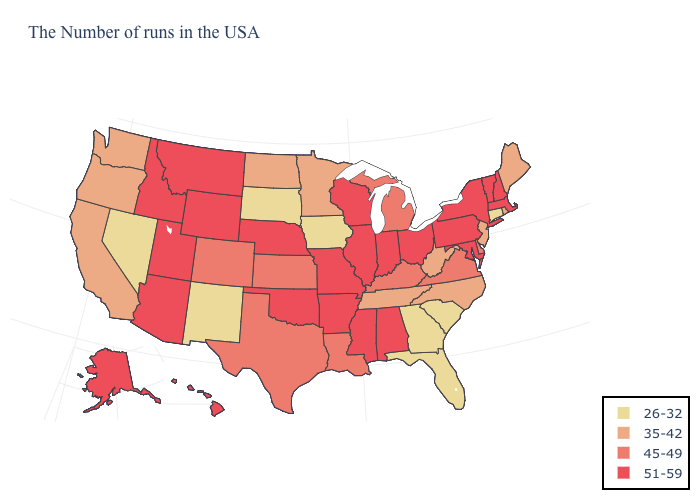Does the first symbol in the legend represent the smallest category?
Be succinct. Yes. What is the value of Idaho?
Short answer required. 51-59. What is the value of Alaska?
Answer briefly. 51-59. Name the states that have a value in the range 51-59?
Concise answer only. Massachusetts, New Hampshire, Vermont, New York, Maryland, Pennsylvania, Ohio, Indiana, Alabama, Wisconsin, Illinois, Mississippi, Missouri, Arkansas, Nebraska, Oklahoma, Wyoming, Utah, Montana, Arizona, Idaho, Alaska, Hawaii. What is the highest value in the MidWest ?
Answer briefly. 51-59. Does Kentucky have the lowest value in the South?
Concise answer only. No. What is the lowest value in the MidWest?
Concise answer only. 26-32. Does New Mexico have the lowest value in the USA?
Keep it brief. Yes. Does the first symbol in the legend represent the smallest category?
Answer briefly. Yes. What is the value of Iowa?
Quick response, please. 26-32. What is the value of Tennessee?
Short answer required. 35-42. What is the value of Nevada?
Be succinct. 26-32. What is the value of Alabama?
Give a very brief answer. 51-59. Does Mississippi have the same value as Nevada?
Be succinct. No. What is the value of Wyoming?
Answer briefly. 51-59. 